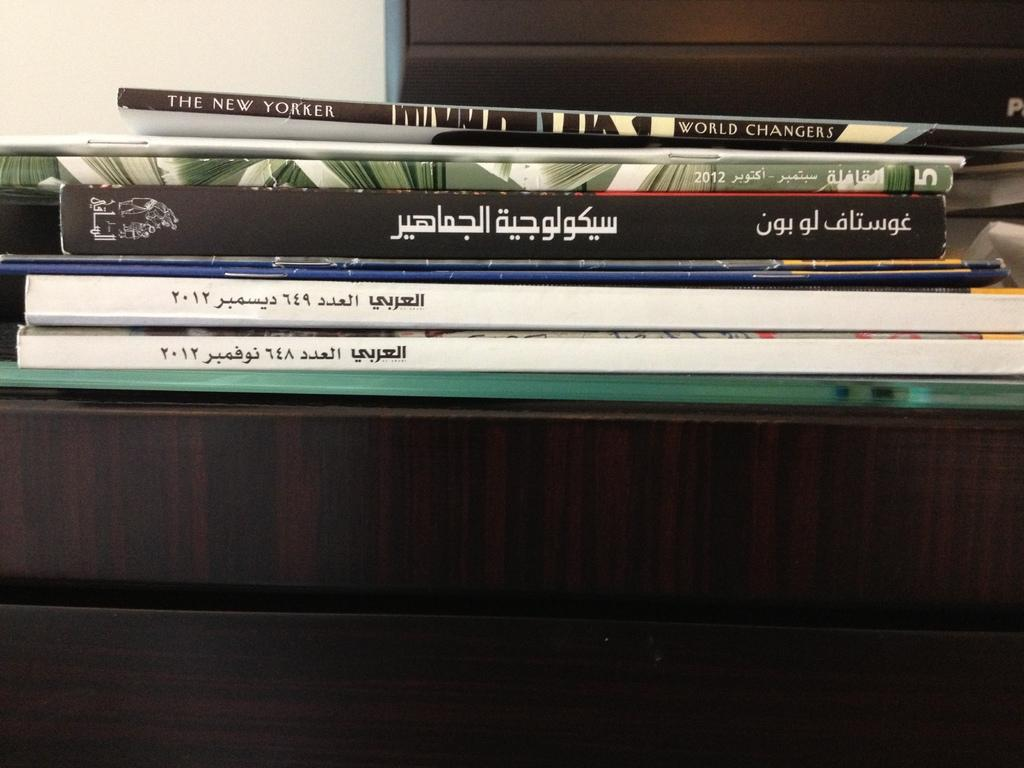What objects are on the desk in the image? There are books on the desk in the image. What material is the desk made of? The desk is made of wood. What can be seen in the background of the image? There is a wall in the background. Is there any source of natural light visible in the image? Yes, there appears to be a window on the right side of the image. What type of dress is the father wearing in the image? There is no father or dress present in the image; it features a desk with books and a wooden surface. 